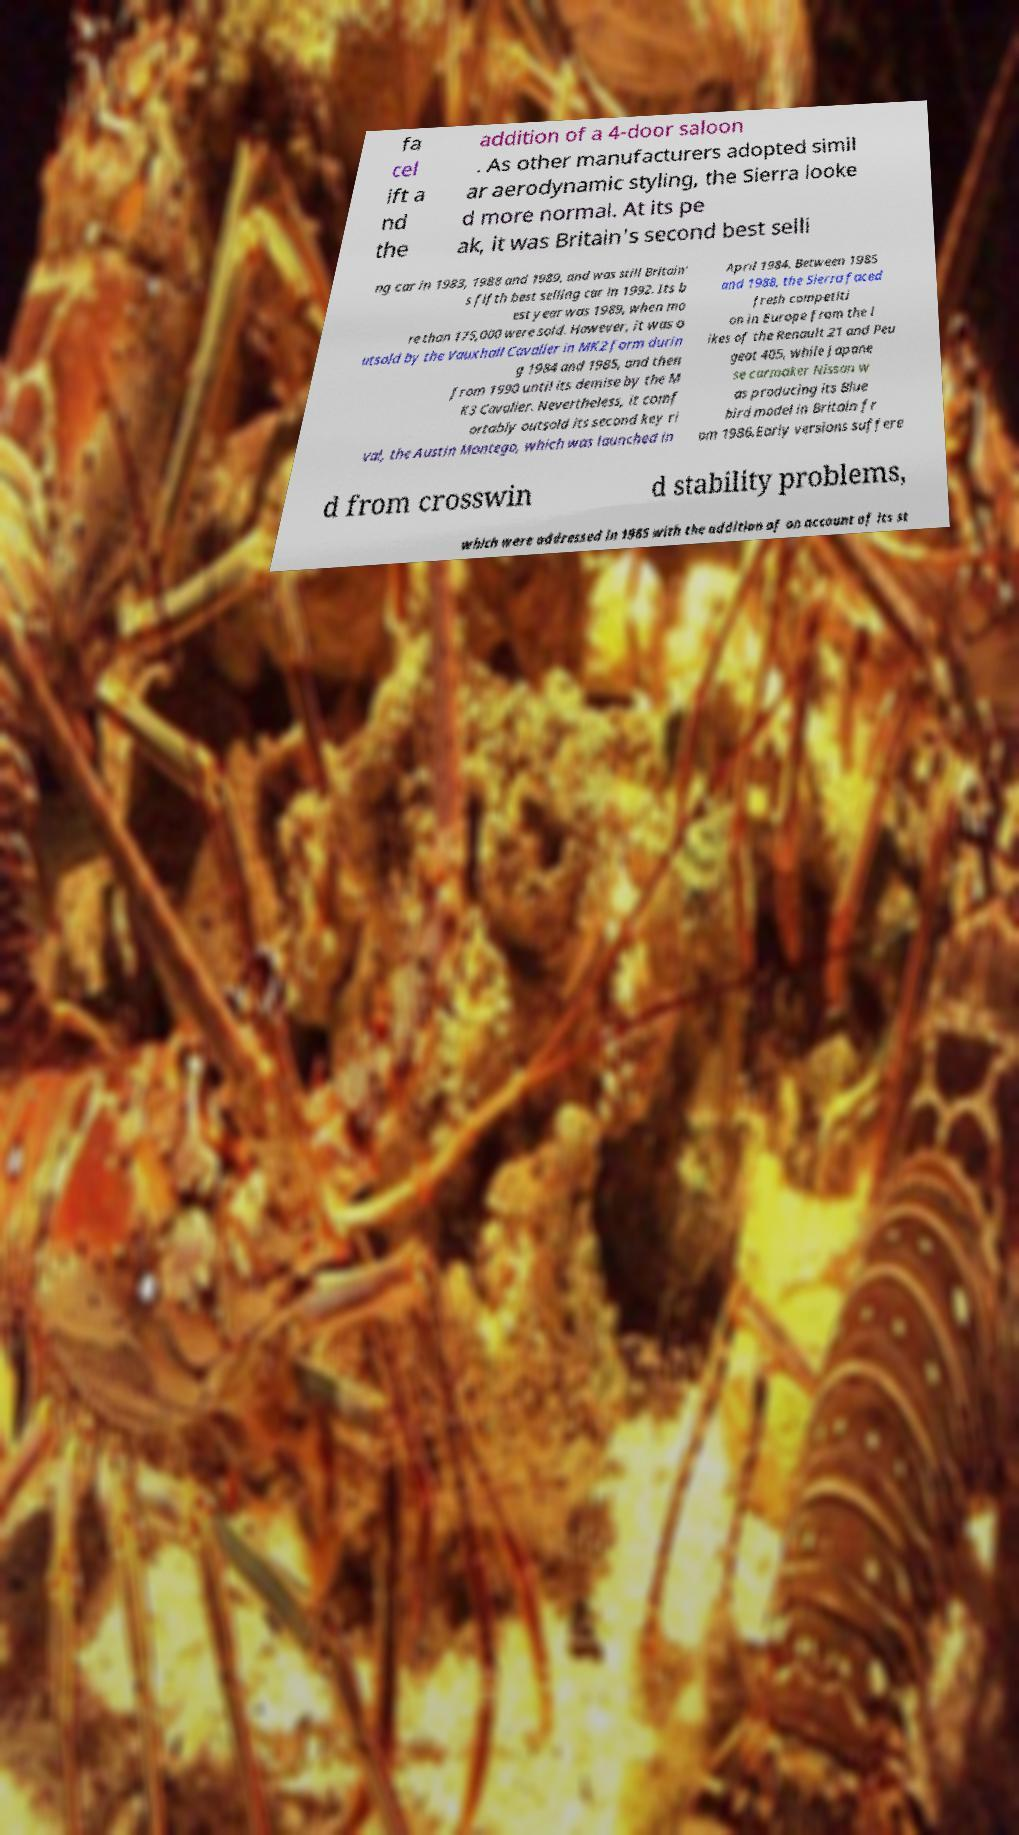Could you assist in decoding the text presented in this image and type it out clearly? fa cel ift a nd the addition of a 4-door saloon . As other manufacturers adopted simil ar aerodynamic styling, the Sierra looke d more normal. At its pe ak, it was Britain's second best selli ng car in 1983, 1988 and 1989, and was still Britain' s fifth best selling car in 1992. Its b est year was 1989, when mo re than 175,000 were sold. However, it was o utsold by the Vauxhall Cavalier in MK2 form durin g 1984 and 1985, and then from 1990 until its demise by the M K3 Cavalier. Nevertheless, it comf ortably outsold its second key ri val, the Austin Montego, which was launched in April 1984. Between 1985 and 1988, the Sierra faced fresh competiti on in Europe from the l ikes of the Renault 21 and Peu geot 405, while Japane se carmaker Nissan w as producing its Blue bird model in Britain fr om 1986.Early versions suffere d from crosswin d stability problems, which were addressed in 1985 with the addition of on account of its st 